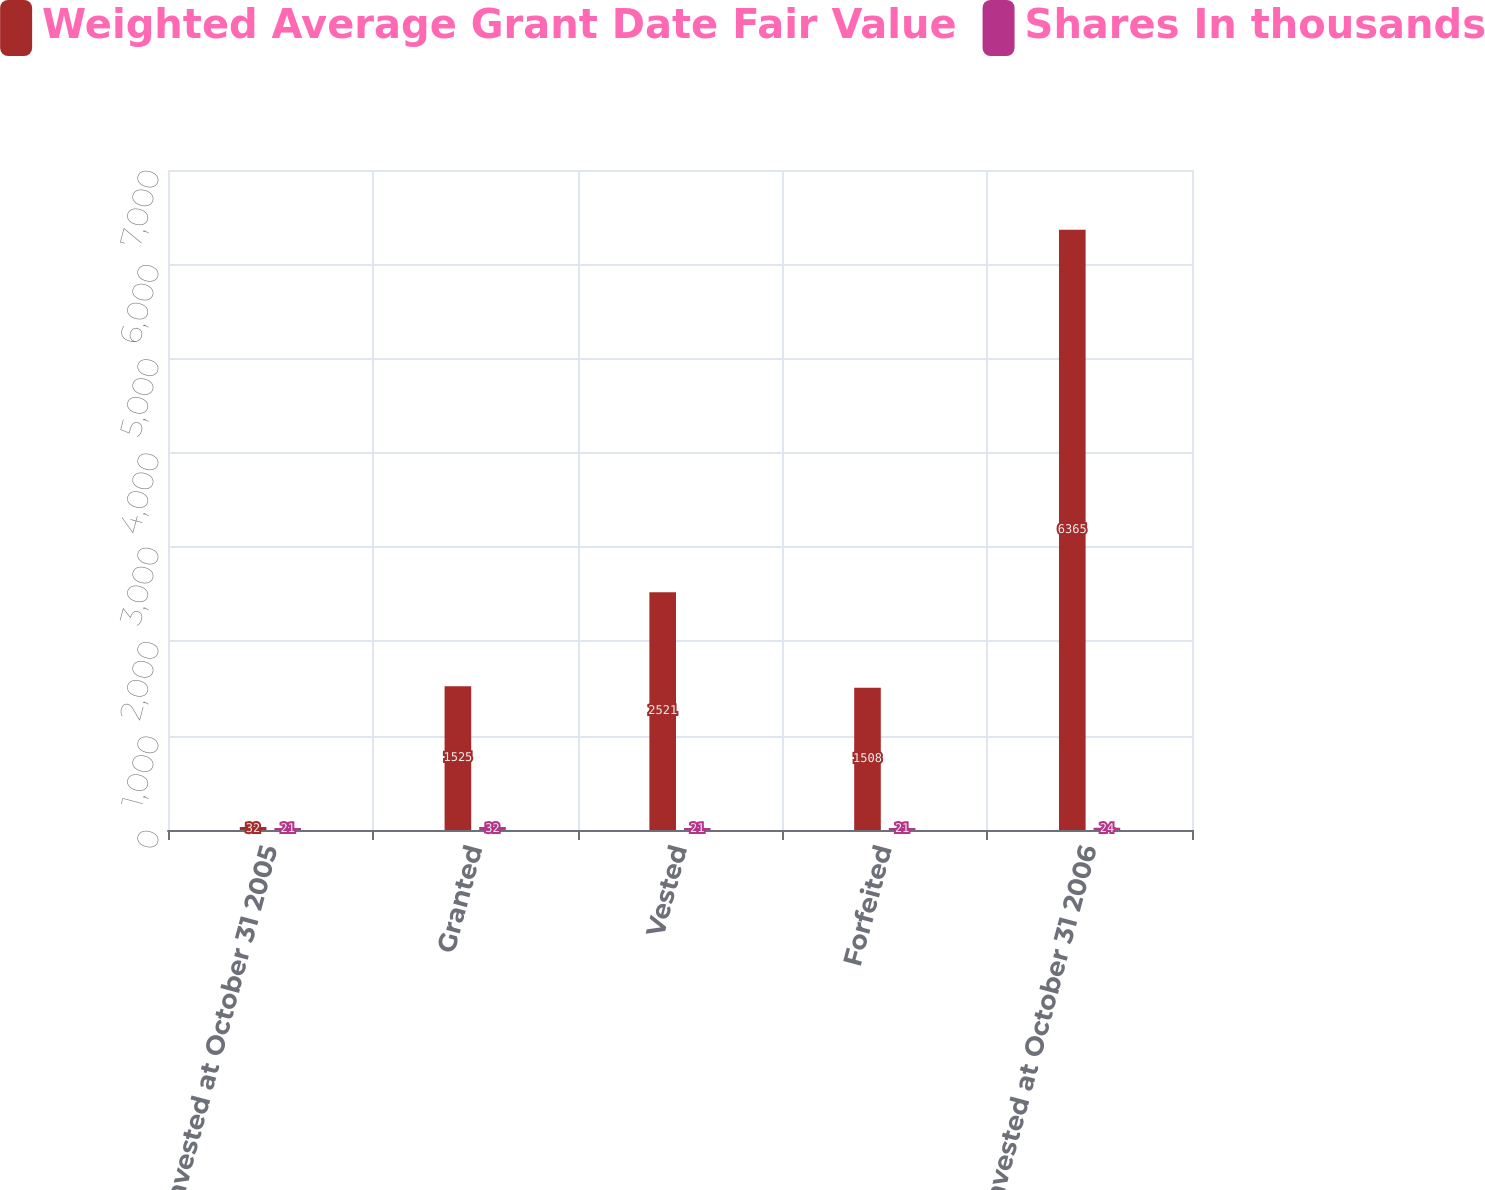Convert chart. <chart><loc_0><loc_0><loc_500><loc_500><stacked_bar_chart><ecel><fcel>Nonvested at October 31 2005<fcel>Granted<fcel>Vested<fcel>Forfeited<fcel>Nonvested at October 31 2006<nl><fcel>Weighted Average Grant Date Fair Value<fcel>32<fcel>1525<fcel>2521<fcel>1508<fcel>6365<nl><fcel>Shares In thousands<fcel>21<fcel>32<fcel>21<fcel>21<fcel>24<nl></chart> 